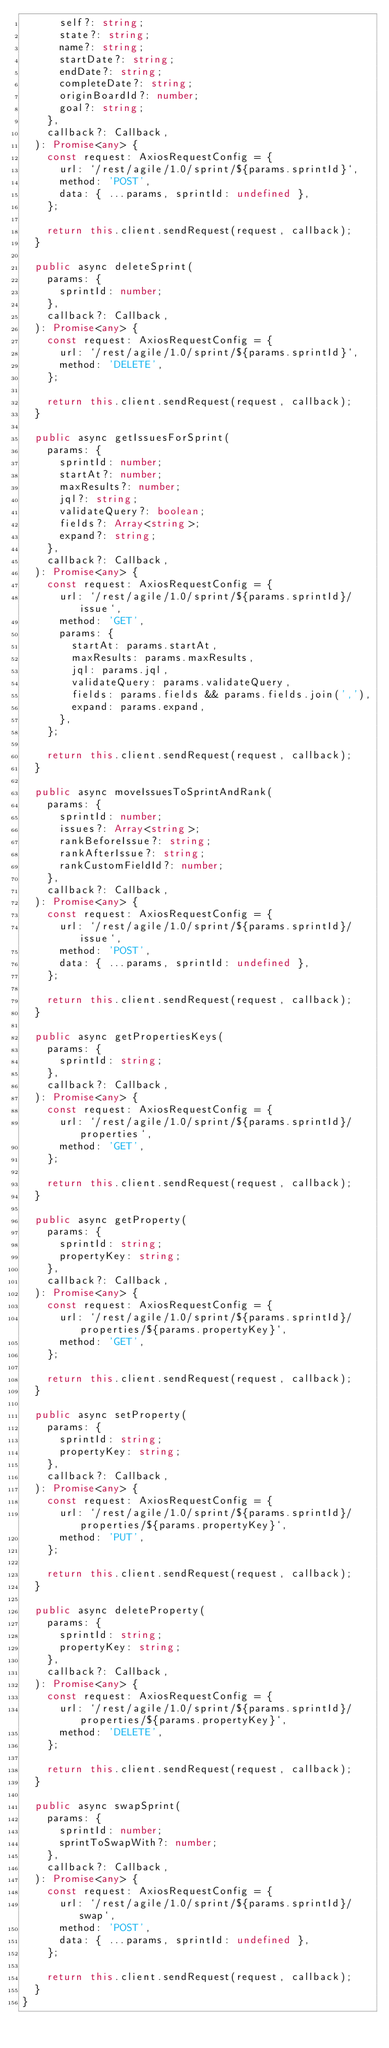Convert code to text. <code><loc_0><loc_0><loc_500><loc_500><_TypeScript_>      self?: string;
      state?: string;
      name?: string;
      startDate?: string;
      endDate?: string;
      completeDate?: string;
      originBoardId?: number;
      goal?: string;
    },
    callback?: Callback,
  ): Promise<any> {
    const request: AxiosRequestConfig = {
      url: `/rest/agile/1.0/sprint/${params.sprintId}`,
      method: 'POST',
      data: { ...params, sprintId: undefined },
    };

    return this.client.sendRequest(request, callback);
  }

  public async deleteSprint(
    params: {
      sprintId: number;
    },
    callback?: Callback,
  ): Promise<any> {
    const request: AxiosRequestConfig = {
      url: `/rest/agile/1.0/sprint/${params.sprintId}`,
      method: 'DELETE',
    };

    return this.client.sendRequest(request, callback);
  }

  public async getIssuesForSprint(
    params: {
      sprintId: number;
      startAt?: number;
      maxResults?: number;
      jql?: string;
      validateQuery?: boolean;
      fields?: Array<string>;
      expand?: string;
    },
    callback?: Callback,
  ): Promise<any> {
    const request: AxiosRequestConfig = {
      url: `/rest/agile/1.0/sprint/${params.sprintId}/issue`,
      method: 'GET',
      params: {
        startAt: params.startAt,
        maxResults: params.maxResults,
        jql: params.jql,
        validateQuery: params.validateQuery,
        fields: params.fields && params.fields.join(','),
        expand: params.expand,
      },
    };

    return this.client.sendRequest(request, callback);
  }

  public async moveIssuesToSprintAndRank(
    params: {
      sprintId: number;
      issues?: Array<string>;
      rankBeforeIssue?: string;
      rankAfterIssue?: string;
      rankCustomFieldId?: number;
    },
    callback?: Callback,
  ): Promise<any> {
    const request: AxiosRequestConfig = {
      url: `/rest/agile/1.0/sprint/${params.sprintId}/issue`,
      method: 'POST',
      data: { ...params, sprintId: undefined },
    };

    return this.client.sendRequest(request, callback);
  }

  public async getPropertiesKeys(
    params: {
      sprintId: string;
    },
    callback?: Callback,
  ): Promise<any> {
    const request: AxiosRequestConfig = {
      url: `/rest/agile/1.0/sprint/${params.sprintId}/properties`,
      method: 'GET',
    };

    return this.client.sendRequest(request, callback);
  }

  public async getProperty(
    params: {
      sprintId: string;
      propertyKey: string;
    },
    callback?: Callback,
  ): Promise<any> {
    const request: AxiosRequestConfig = {
      url: `/rest/agile/1.0/sprint/${params.sprintId}/properties/${params.propertyKey}`,
      method: 'GET',
    };

    return this.client.sendRequest(request, callback);
  }

  public async setProperty(
    params: {
      sprintId: string;
      propertyKey: string;
    },
    callback?: Callback,
  ): Promise<any> {
    const request: AxiosRequestConfig = {
      url: `/rest/agile/1.0/sprint/${params.sprintId}/properties/${params.propertyKey}`,
      method: 'PUT',
    };

    return this.client.sendRequest(request, callback);
  }

  public async deleteProperty(
    params: {
      sprintId: string;
      propertyKey: string;
    },
    callback?: Callback,
  ): Promise<any> {
    const request: AxiosRequestConfig = {
      url: `/rest/agile/1.0/sprint/${params.sprintId}/properties/${params.propertyKey}`,
      method: 'DELETE',
    };

    return this.client.sendRequest(request, callback);
  }

  public async swapSprint(
    params: {
      sprintId: number;
      sprintToSwapWith?: number;
    },
    callback?: Callback,
  ): Promise<any> {
    const request: AxiosRequestConfig = {
      url: `/rest/agile/1.0/sprint/${params.sprintId}/swap`,
      method: 'POST',
      data: { ...params, sprintId: undefined },
    };

    return this.client.sendRequest(request, callback);
  }
}
</code> 